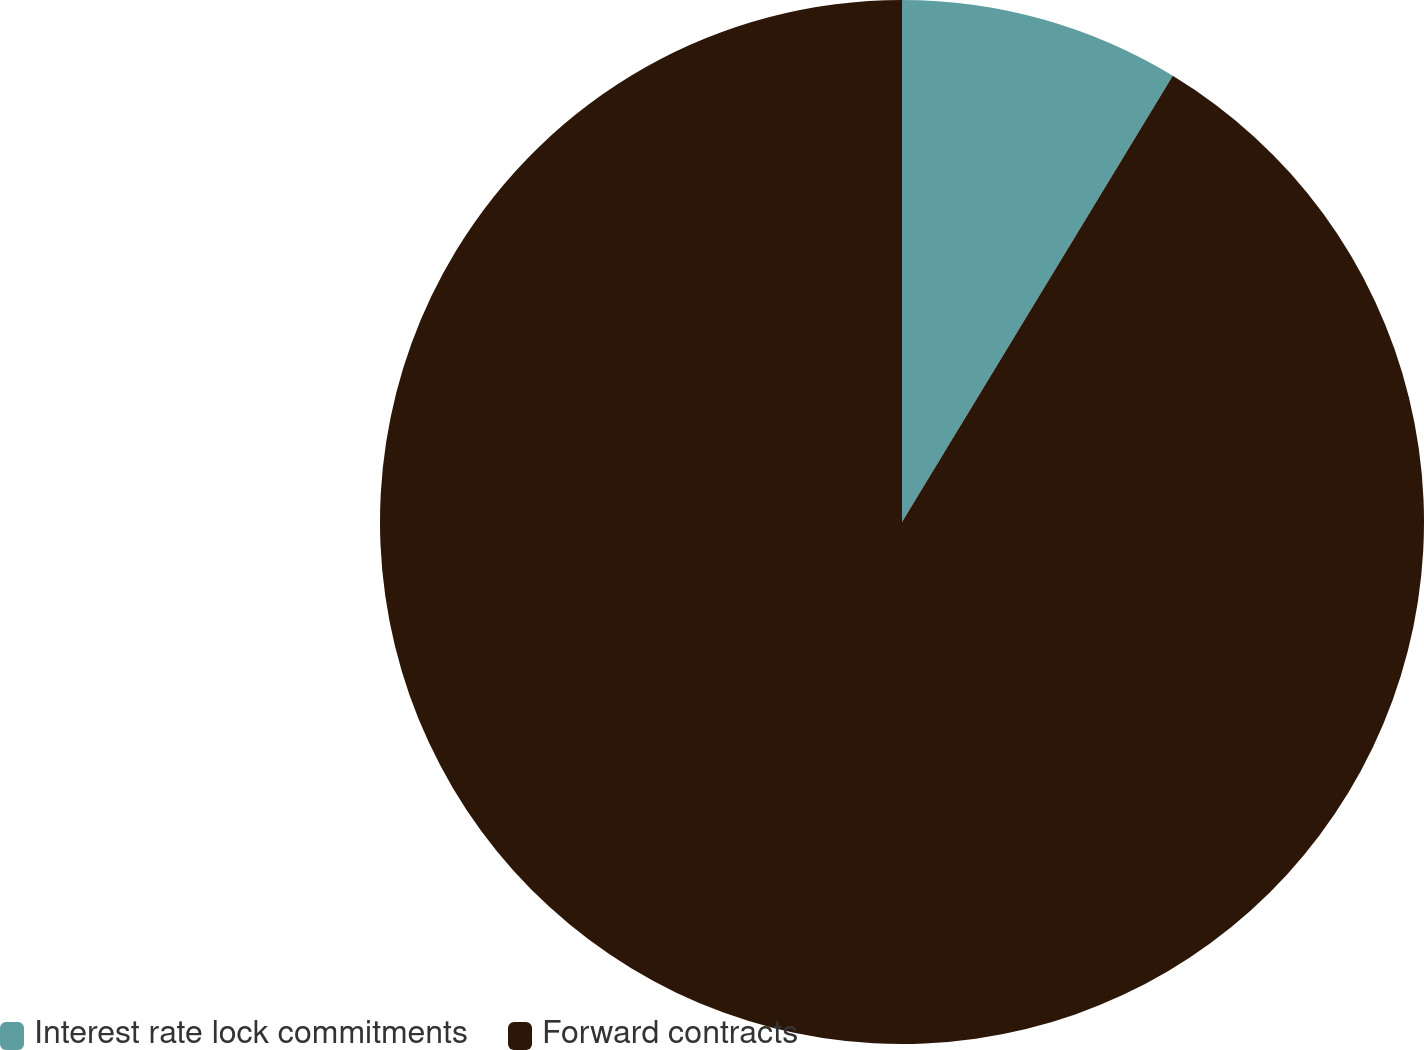Convert chart to OTSL. <chart><loc_0><loc_0><loc_500><loc_500><pie_chart><fcel>Interest rate lock commitments<fcel>Forward contracts<nl><fcel>8.68%<fcel>91.32%<nl></chart> 